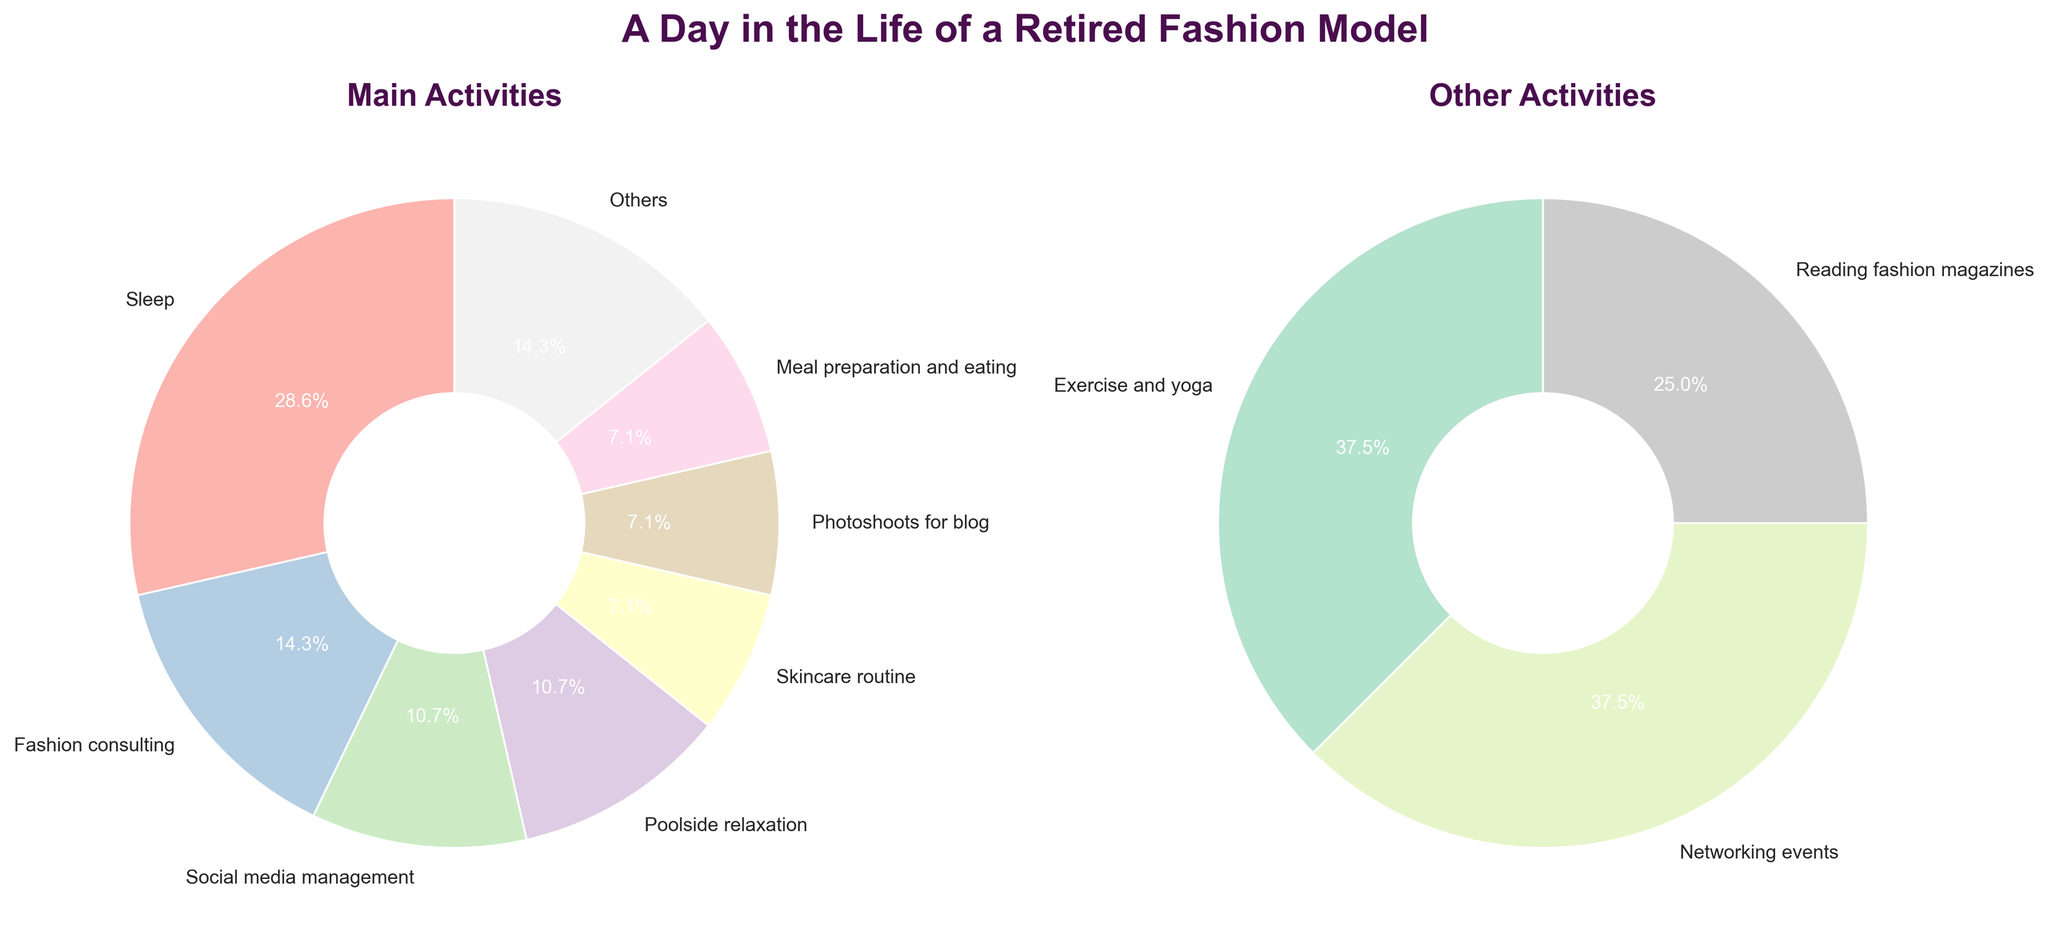What is the title of the main activities pie chart? The title of the main activities pie chart can be found at the top of the chart labeled 'Main Activities'.
Answer: Main Activities How many activities are categorized as main activities? Count the number of labels on the main activities pie chart.
Answer: 6 Which activity takes up the largest portion in the main activities pie chart? Identify the segment with the largest percentage on the main activities pie chart.
Answer: Sleep What percentage of time is spent on poolside relaxation? Look for the segment labeled 'Poolside relaxation' on the main activities pie chart and read the percentage.
Answer: 15.0% Which two activities have the smallest share in the other activities pie chart? Identify the two smallest segments by percentage on the other activities pie chart.
Answer: Reading fashion magazines, Networking events How does the time spent on social media management compare to meal preparation and eating? Compare the segments labeled 'Social media management' and 'Meal preparation and eating' in the main activities pie chart.
Answer: Social media management is greater Which category consumes more time, exercise and yoga or meal preparation and eating? Compare the segments labeled 'Exercise and yoga' and 'Meal preparation and eating' in the main activities pie chart.
Answer: Meal preparation and eating What is the combined percentage of time allocated to social media management and photoshoots for the blog? Add the percentages of the segments labeled 'Social media management' and 'Photoshoots for blog' in the main activities pie chart.
Answer: 25.0% How many activities are shown in the other activities pie chart? Count the number of labels on the other activities pie chart.
Answer: 4 What other activities have the same percentage of time allocation? Identify segments with the same percentage on the other activities pie chart.
Answer: Exercise and yoga, Networking events 